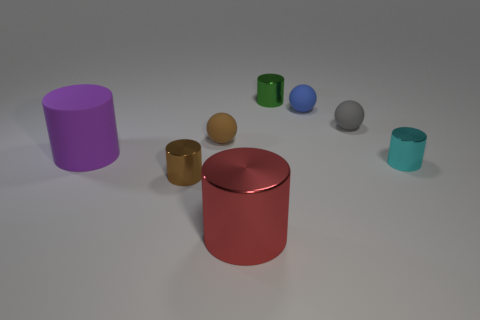What number of objects are gray rubber things or tiny brown cylinders?
Your answer should be compact. 2. There is a large object that is behind the big cylinder on the right side of the big matte cylinder; what is its material?
Ensure brevity in your answer.  Rubber. What number of other things have the same shape as the tiny blue object?
Provide a short and direct response. 2. What number of objects are rubber spheres that are on the left side of the big red thing or big things in front of the cyan cylinder?
Provide a short and direct response. 2. There is a thing that is in front of the brown shiny thing; is there a big red metallic thing behind it?
Your answer should be compact. No. There is a brown metallic thing that is the same size as the green metallic cylinder; what shape is it?
Your answer should be very brief. Cylinder. What number of things are either small blue balls that are right of the big red metallic object or big blue metal balls?
Keep it short and to the point. 1. What number of other things are made of the same material as the brown ball?
Your answer should be compact. 3. There is a blue rubber sphere that is behind the red cylinder; what size is it?
Offer a very short reply. Small. There is a tiny gray thing that is the same material as the tiny blue thing; what is its shape?
Ensure brevity in your answer.  Sphere. 